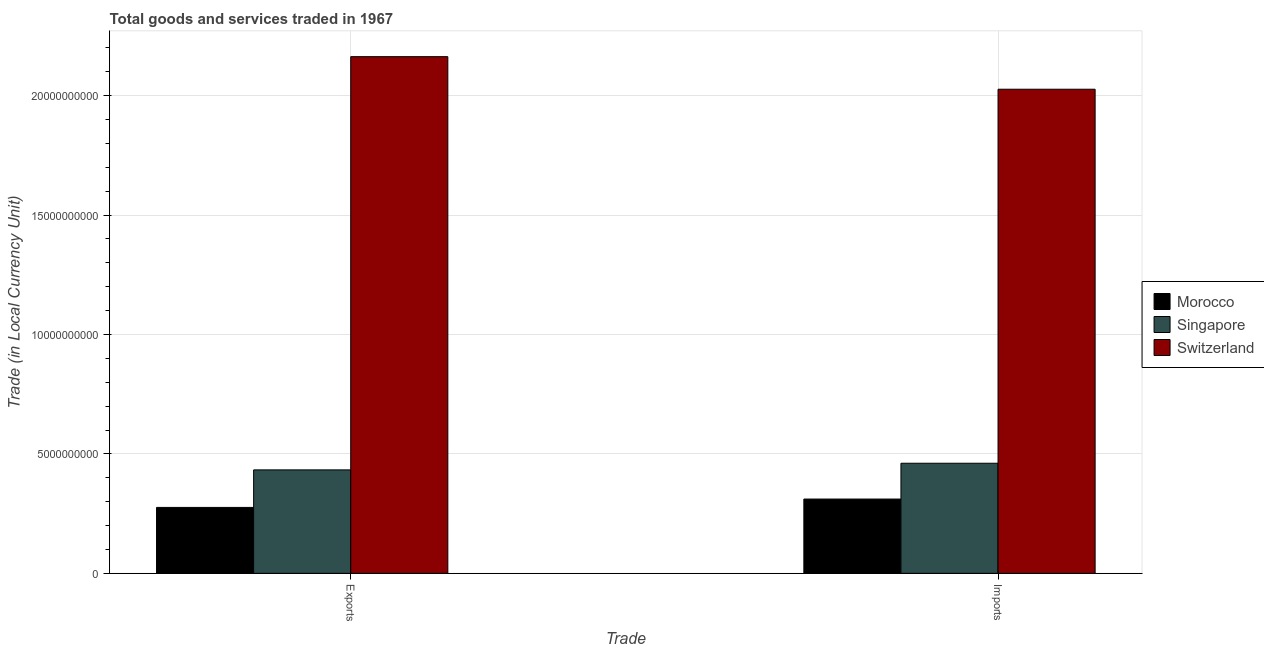How many different coloured bars are there?
Offer a terse response. 3. What is the label of the 1st group of bars from the left?
Make the answer very short. Exports. What is the imports of goods and services in Morocco?
Your answer should be very brief. 3.11e+09. Across all countries, what is the maximum imports of goods and services?
Offer a very short reply. 2.03e+1. Across all countries, what is the minimum export of goods and services?
Ensure brevity in your answer.  2.76e+09. In which country was the export of goods and services maximum?
Ensure brevity in your answer.  Switzerland. In which country was the imports of goods and services minimum?
Make the answer very short. Morocco. What is the total imports of goods and services in the graph?
Offer a terse response. 2.80e+1. What is the difference between the imports of goods and services in Morocco and that in Singapore?
Provide a short and direct response. -1.50e+09. What is the difference between the imports of goods and services in Morocco and the export of goods and services in Switzerland?
Your response must be concise. -1.85e+1. What is the average export of goods and services per country?
Offer a very short reply. 9.58e+09. What is the difference between the export of goods and services and imports of goods and services in Switzerland?
Provide a short and direct response. 1.36e+09. In how many countries, is the export of goods and services greater than 6000000000 LCU?
Your answer should be very brief. 1. What is the ratio of the export of goods and services in Singapore to that in Morocco?
Offer a terse response. 1.57. Is the imports of goods and services in Morocco less than that in Singapore?
Your response must be concise. Yes. In how many countries, is the imports of goods and services greater than the average imports of goods and services taken over all countries?
Give a very brief answer. 1. What does the 3rd bar from the left in Imports represents?
Provide a succinct answer. Switzerland. What does the 1st bar from the right in Exports represents?
Offer a very short reply. Switzerland. How many countries are there in the graph?
Your answer should be very brief. 3. What is the difference between two consecutive major ticks on the Y-axis?
Provide a succinct answer. 5.00e+09. Are the values on the major ticks of Y-axis written in scientific E-notation?
Offer a terse response. No. Does the graph contain any zero values?
Give a very brief answer. No. Does the graph contain grids?
Your answer should be compact. Yes. Where does the legend appear in the graph?
Keep it short and to the point. Center right. How are the legend labels stacked?
Ensure brevity in your answer.  Vertical. What is the title of the graph?
Provide a succinct answer. Total goods and services traded in 1967. Does "Least developed countries" appear as one of the legend labels in the graph?
Make the answer very short. No. What is the label or title of the X-axis?
Give a very brief answer. Trade. What is the label or title of the Y-axis?
Offer a very short reply. Trade (in Local Currency Unit). What is the Trade (in Local Currency Unit) of Morocco in Exports?
Your answer should be very brief. 2.76e+09. What is the Trade (in Local Currency Unit) in Singapore in Exports?
Offer a terse response. 4.33e+09. What is the Trade (in Local Currency Unit) of Switzerland in Exports?
Offer a terse response. 2.16e+1. What is the Trade (in Local Currency Unit) of Morocco in Imports?
Your answer should be compact. 3.11e+09. What is the Trade (in Local Currency Unit) in Singapore in Imports?
Keep it short and to the point. 4.61e+09. What is the Trade (in Local Currency Unit) in Switzerland in Imports?
Provide a short and direct response. 2.03e+1. Across all Trade, what is the maximum Trade (in Local Currency Unit) in Morocco?
Your answer should be very brief. 3.11e+09. Across all Trade, what is the maximum Trade (in Local Currency Unit) in Singapore?
Keep it short and to the point. 4.61e+09. Across all Trade, what is the maximum Trade (in Local Currency Unit) in Switzerland?
Give a very brief answer. 2.16e+1. Across all Trade, what is the minimum Trade (in Local Currency Unit) in Morocco?
Offer a terse response. 2.76e+09. Across all Trade, what is the minimum Trade (in Local Currency Unit) in Singapore?
Offer a very short reply. 4.33e+09. Across all Trade, what is the minimum Trade (in Local Currency Unit) in Switzerland?
Provide a short and direct response. 2.03e+1. What is the total Trade (in Local Currency Unit) of Morocco in the graph?
Provide a short and direct response. 5.87e+09. What is the total Trade (in Local Currency Unit) of Singapore in the graph?
Offer a terse response. 8.94e+09. What is the total Trade (in Local Currency Unit) in Switzerland in the graph?
Give a very brief answer. 4.19e+1. What is the difference between the Trade (in Local Currency Unit) of Morocco in Exports and that in Imports?
Give a very brief answer. -3.50e+08. What is the difference between the Trade (in Local Currency Unit) of Singapore in Exports and that in Imports?
Make the answer very short. -2.78e+08. What is the difference between the Trade (in Local Currency Unit) of Switzerland in Exports and that in Imports?
Your answer should be compact. 1.36e+09. What is the difference between the Trade (in Local Currency Unit) in Morocco in Exports and the Trade (in Local Currency Unit) in Singapore in Imports?
Make the answer very short. -1.85e+09. What is the difference between the Trade (in Local Currency Unit) of Morocco in Exports and the Trade (in Local Currency Unit) of Switzerland in Imports?
Give a very brief answer. -1.75e+1. What is the difference between the Trade (in Local Currency Unit) of Singapore in Exports and the Trade (in Local Currency Unit) of Switzerland in Imports?
Make the answer very short. -1.59e+1. What is the average Trade (in Local Currency Unit) in Morocco per Trade?
Make the answer very short. 2.94e+09. What is the average Trade (in Local Currency Unit) of Singapore per Trade?
Your answer should be compact. 4.47e+09. What is the average Trade (in Local Currency Unit) of Switzerland per Trade?
Your answer should be compact. 2.10e+1. What is the difference between the Trade (in Local Currency Unit) in Morocco and Trade (in Local Currency Unit) in Singapore in Exports?
Offer a terse response. -1.57e+09. What is the difference between the Trade (in Local Currency Unit) of Morocco and Trade (in Local Currency Unit) of Switzerland in Exports?
Provide a succinct answer. -1.89e+1. What is the difference between the Trade (in Local Currency Unit) in Singapore and Trade (in Local Currency Unit) in Switzerland in Exports?
Provide a short and direct response. -1.73e+1. What is the difference between the Trade (in Local Currency Unit) in Morocco and Trade (in Local Currency Unit) in Singapore in Imports?
Provide a short and direct response. -1.50e+09. What is the difference between the Trade (in Local Currency Unit) in Morocco and Trade (in Local Currency Unit) in Switzerland in Imports?
Provide a short and direct response. -1.72e+1. What is the difference between the Trade (in Local Currency Unit) in Singapore and Trade (in Local Currency Unit) in Switzerland in Imports?
Your response must be concise. -1.57e+1. What is the ratio of the Trade (in Local Currency Unit) of Morocco in Exports to that in Imports?
Offer a terse response. 0.89. What is the ratio of the Trade (in Local Currency Unit) of Singapore in Exports to that in Imports?
Give a very brief answer. 0.94. What is the ratio of the Trade (in Local Currency Unit) of Switzerland in Exports to that in Imports?
Keep it short and to the point. 1.07. What is the difference between the highest and the second highest Trade (in Local Currency Unit) of Morocco?
Ensure brevity in your answer.  3.50e+08. What is the difference between the highest and the second highest Trade (in Local Currency Unit) of Singapore?
Your response must be concise. 2.78e+08. What is the difference between the highest and the second highest Trade (in Local Currency Unit) in Switzerland?
Provide a succinct answer. 1.36e+09. What is the difference between the highest and the lowest Trade (in Local Currency Unit) of Morocco?
Offer a terse response. 3.50e+08. What is the difference between the highest and the lowest Trade (in Local Currency Unit) in Singapore?
Offer a very short reply. 2.78e+08. What is the difference between the highest and the lowest Trade (in Local Currency Unit) of Switzerland?
Give a very brief answer. 1.36e+09. 